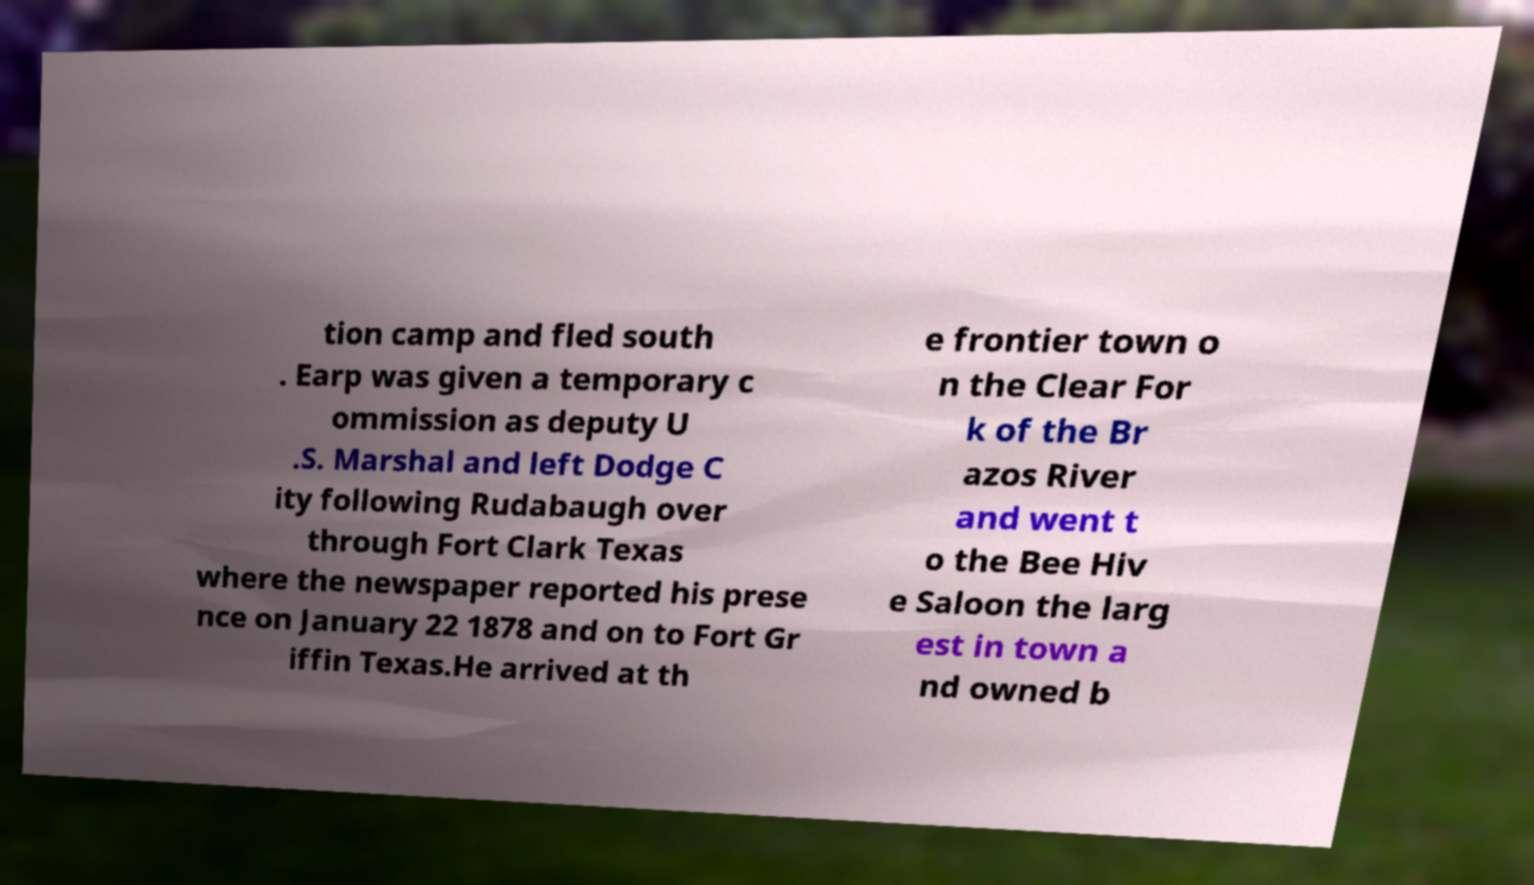I need the written content from this picture converted into text. Can you do that? tion camp and fled south . Earp was given a temporary c ommission as deputy U .S. Marshal and left Dodge C ity following Rudabaugh over through Fort Clark Texas where the newspaper reported his prese nce on January 22 1878 and on to Fort Gr iffin Texas.He arrived at th e frontier town o n the Clear For k of the Br azos River and went t o the Bee Hiv e Saloon the larg est in town a nd owned b 